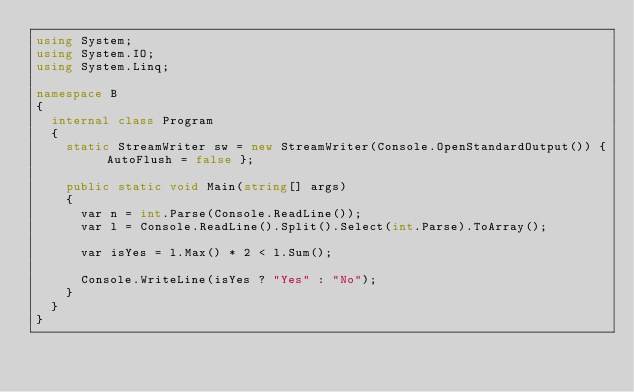<code> <loc_0><loc_0><loc_500><loc_500><_C#_>using System;
using System.IO;
using System.Linq;

namespace B
{
	internal class Program
	{
		static StreamWriter sw = new StreamWriter(Console.OpenStandardOutput()) { AutoFlush = false };

		public static void Main(string[] args)
		{
			var n = int.Parse(Console.ReadLine());
			var l = Console.ReadLine().Split().Select(int.Parse).ToArray();

			var isYes = l.Max() * 2 < l.Sum();

			Console.WriteLine(isYes ? "Yes" : "No");
		}
	}
}</code> 